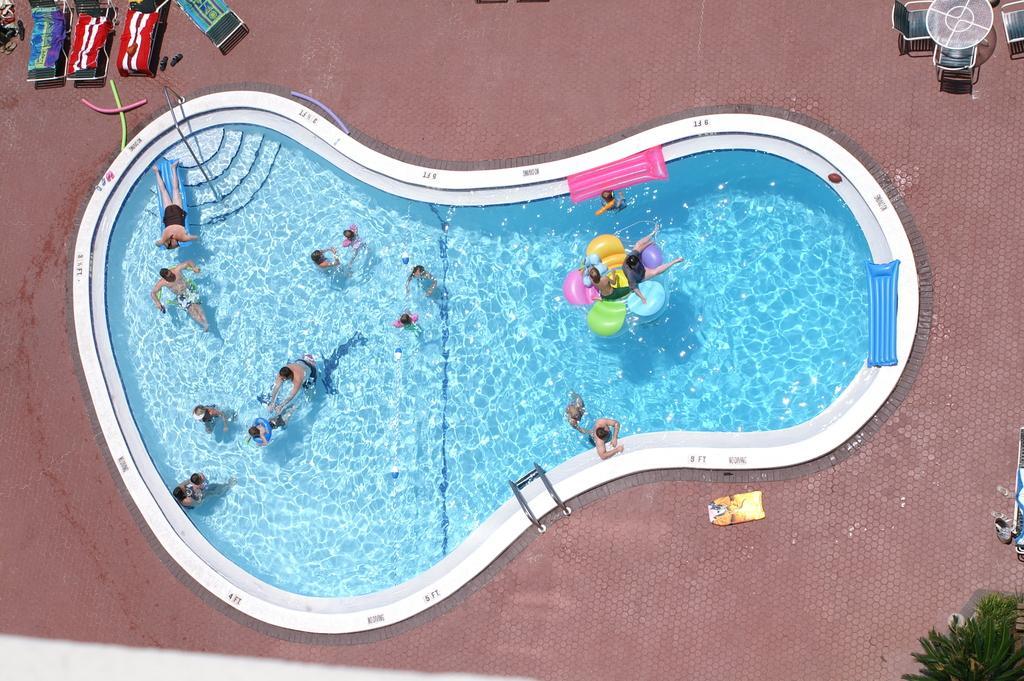Please provide a concise description of this image. In this picture we can see the top view of a swimming pool with blue water and people playing inside it. 